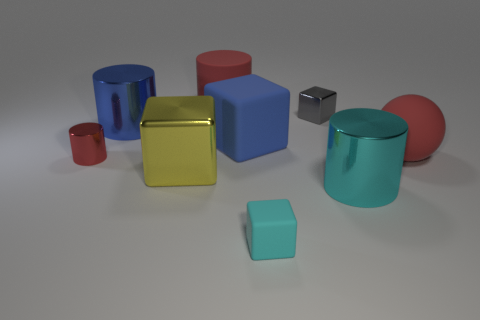Subtract 2 blocks. How many blocks are left? 2 Subtract all cyan blocks. How many blocks are left? 3 Add 1 blue metallic objects. How many objects exist? 10 Subtract all cylinders. How many objects are left? 5 Subtract all cyan cylinders. Subtract all cyan metallic cylinders. How many objects are left? 7 Add 6 small red metal things. How many small red metal things are left? 7 Add 4 red blocks. How many red blocks exist? 4 Subtract 1 blue blocks. How many objects are left? 8 